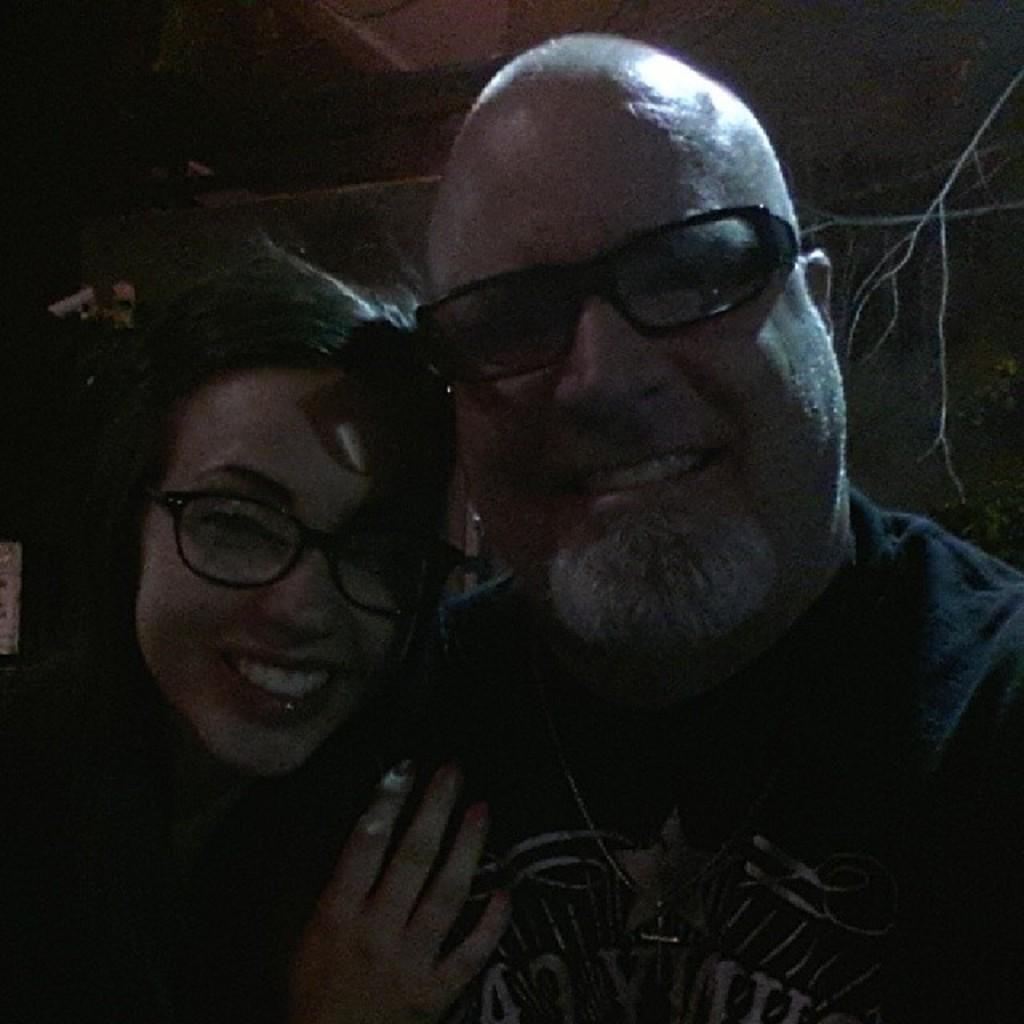In one or two sentences, can you explain what this image depicts? This is an image clicked in the dark. Here I can see a man and a woman are smiling and giving pose for the picture. 